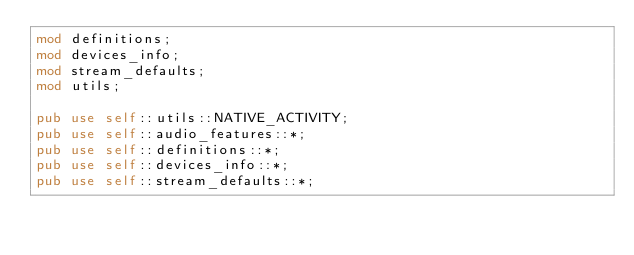Convert code to text. <code><loc_0><loc_0><loc_500><loc_500><_Rust_>mod definitions;
mod devices_info;
mod stream_defaults;
mod utils;

pub use self::utils::NATIVE_ACTIVITY;
pub use self::audio_features::*;
pub use self::definitions::*;
pub use self::devices_info::*;
pub use self::stream_defaults::*;
</code> 